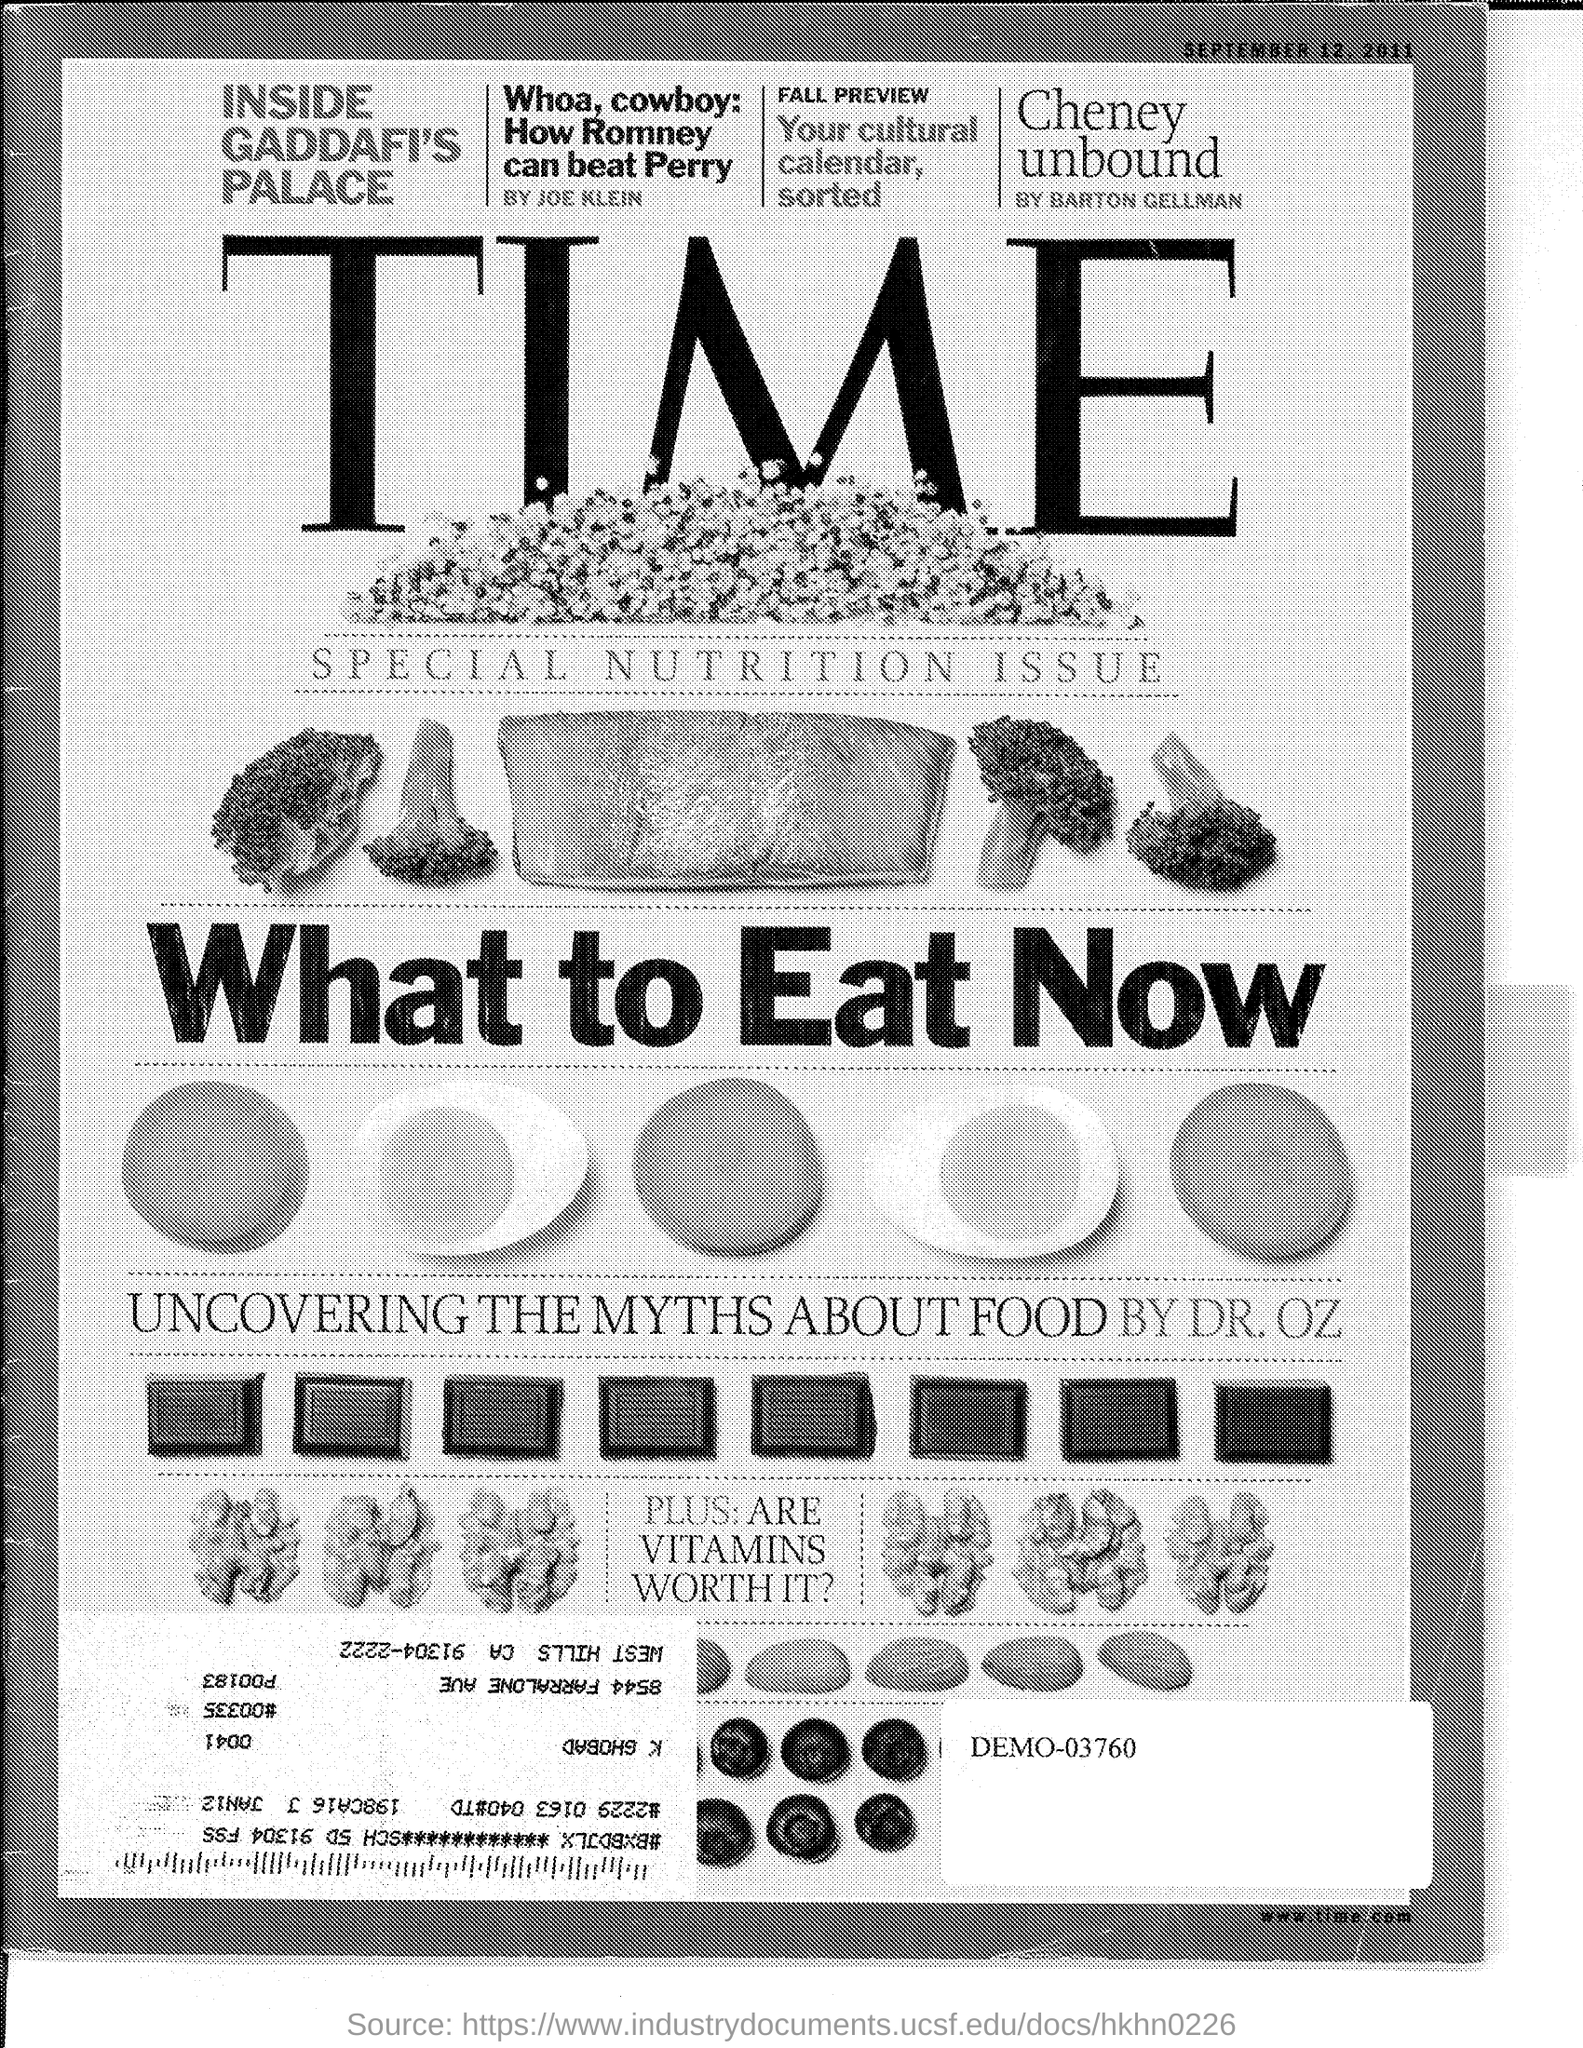Outline some significant characteristics in this image. Joe Klein wrote an article titled 'Whoa, cowboy: How Romney can beat Perry.' The demo number mentioned is 03760.. The date displayed at the top right of the page is September 12, 2011. The website mentioned at the right bottom corner of the screen is [www.time.com](http://www.time.com). The article uncovering the myths about food was written by Dr. Oz. 